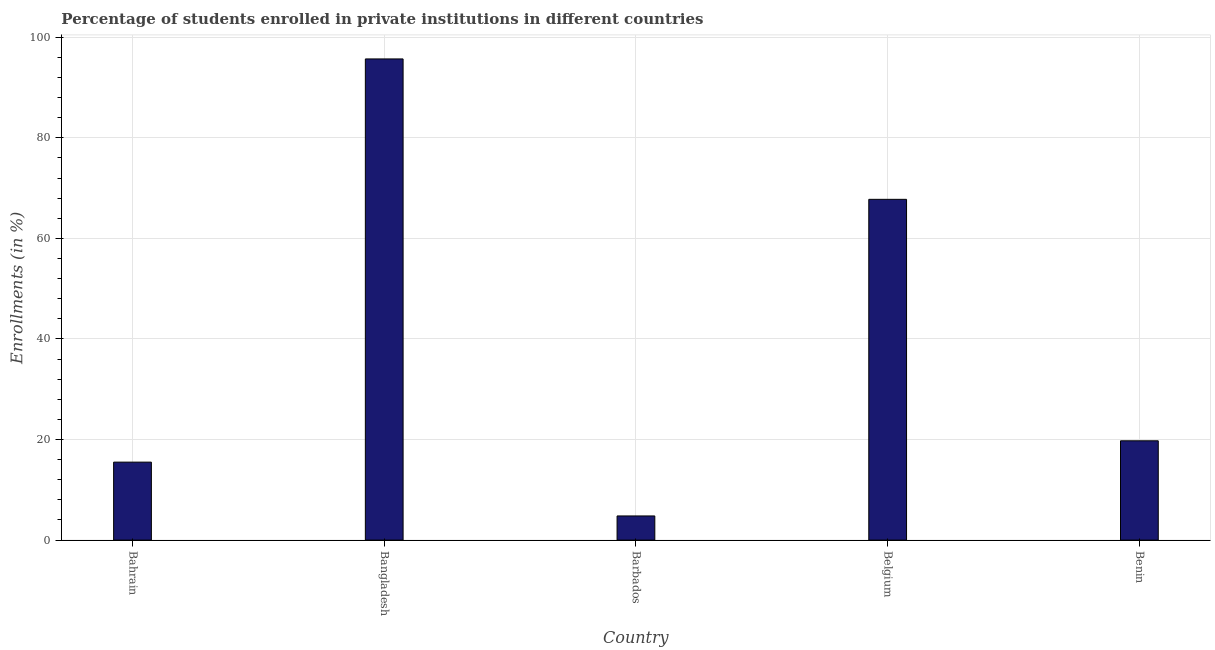Does the graph contain grids?
Your answer should be compact. Yes. What is the title of the graph?
Keep it short and to the point. Percentage of students enrolled in private institutions in different countries. What is the label or title of the Y-axis?
Offer a very short reply. Enrollments (in %). What is the enrollments in private institutions in Benin?
Ensure brevity in your answer.  19.75. Across all countries, what is the maximum enrollments in private institutions?
Give a very brief answer. 95.69. Across all countries, what is the minimum enrollments in private institutions?
Give a very brief answer. 4.8. In which country was the enrollments in private institutions minimum?
Your answer should be very brief. Barbados. What is the sum of the enrollments in private institutions?
Provide a succinct answer. 203.51. What is the difference between the enrollments in private institutions in Bangladesh and Barbados?
Ensure brevity in your answer.  90.88. What is the average enrollments in private institutions per country?
Provide a short and direct response. 40.7. What is the median enrollments in private institutions?
Make the answer very short. 19.75. What is the ratio of the enrollments in private institutions in Bangladesh to that in Benin?
Ensure brevity in your answer.  4.85. What is the difference between the highest and the second highest enrollments in private institutions?
Your response must be concise. 27.92. What is the difference between the highest and the lowest enrollments in private institutions?
Your response must be concise. 90.88. In how many countries, is the enrollments in private institutions greater than the average enrollments in private institutions taken over all countries?
Offer a terse response. 2. How many bars are there?
Keep it short and to the point. 5. Are all the bars in the graph horizontal?
Keep it short and to the point. No. What is the difference between two consecutive major ticks on the Y-axis?
Your response must be concise. 20. What is the Enrollments (in %) of Bahrain?
Keep it short and to the point. 15.5. What is the Enrollments (in %) of Bangladesh?
Offer a terse response. 95.69. What is the Enrollments (in %) of Barbados?
Ensure brevity in your answer.  4.8. What is the Enrollments (in %) in Belgium?
Ensure brevity in your answer.  67.77. What is the Enrollments (in %) in Benin?
Offer a very short reply. 19.75. What is the difference between the Enrollments (in %) in Bahrain and Bangladesh?
Give a very brief answer. -80.18. What is the difference between the Enrollments (in %) in Bahrain and Barbados?
Ensure brevity in your answer.  10.7. What is the difference between the Enrollments (in %) in Bahrain and Belgium?
Make the answer very short. -52.26. What is the difference between the Enrollments (in %) in Bahrain and Benin?
Your answer should be compact. -4.24. What is the difference between the Enrollments (in %) in Bangladesh and Barbados?
Keep it short and to the point. 90.88. What is the difference between the Enrollments (in %) in Bangladesh and Belgium?
Provide a succinct answer. 27.92. What is the difference between the Enrollments (in %) in Bangladesh and Benin?
Keep it short and to the point. 75.94. What is the difference between the Enrollments (in %) in Barbados and Belgium?
Make the answer very short. -62.96. What is the difference between the Enrollments (in %) in Barbados and Benin?
Provide a short and direct response. -14.94. What is the difference between the Enrollments (in %) in Belgium and Benin?
Offer a very short reply. 48.02. What is the ratio of the Enrollments (in %) in Bahrain to that in Bangladesh?
Your answer should be very brief. 0.16. What is the ratio of the Enrollments (in %) in Bahrain to that in Barbados?
Your response must be concise. 3.23. What is the ratio of the Enrollments (in %) in Bahrain to that in Belgium?
Provide a succinct answer. 0.23. What is the ratio of the Enrollments (in %) in Bahrain to that in Benin?
Keep it short and to the point. 0.79. What is the ratio of the Enrollments (in %) in Bangladesh to that in Barbados?
Provide a short and direct response. 19.92. What is the ratio of the Enrollments (in %) in Bangladesh to that in Belgium?
Keep it short and to the point. 1.41. What is the ratio of the Enrollments (in %) in Bangladesh to that in Benin?
Provide a succinct answer. 4.85. What is the ratio of the Enrollments (in %) in Barbados to that in Belgium?
Your answer should be very brief. 0.07. What is the ratio of the Enrollments (in %) in Barbados to that in Benin?
Keep it short and to the point. 0.24. What is the ratio of the Enrollments (in %) in Belgium to that in Benin?
Give a very brief answer. 3.43. 